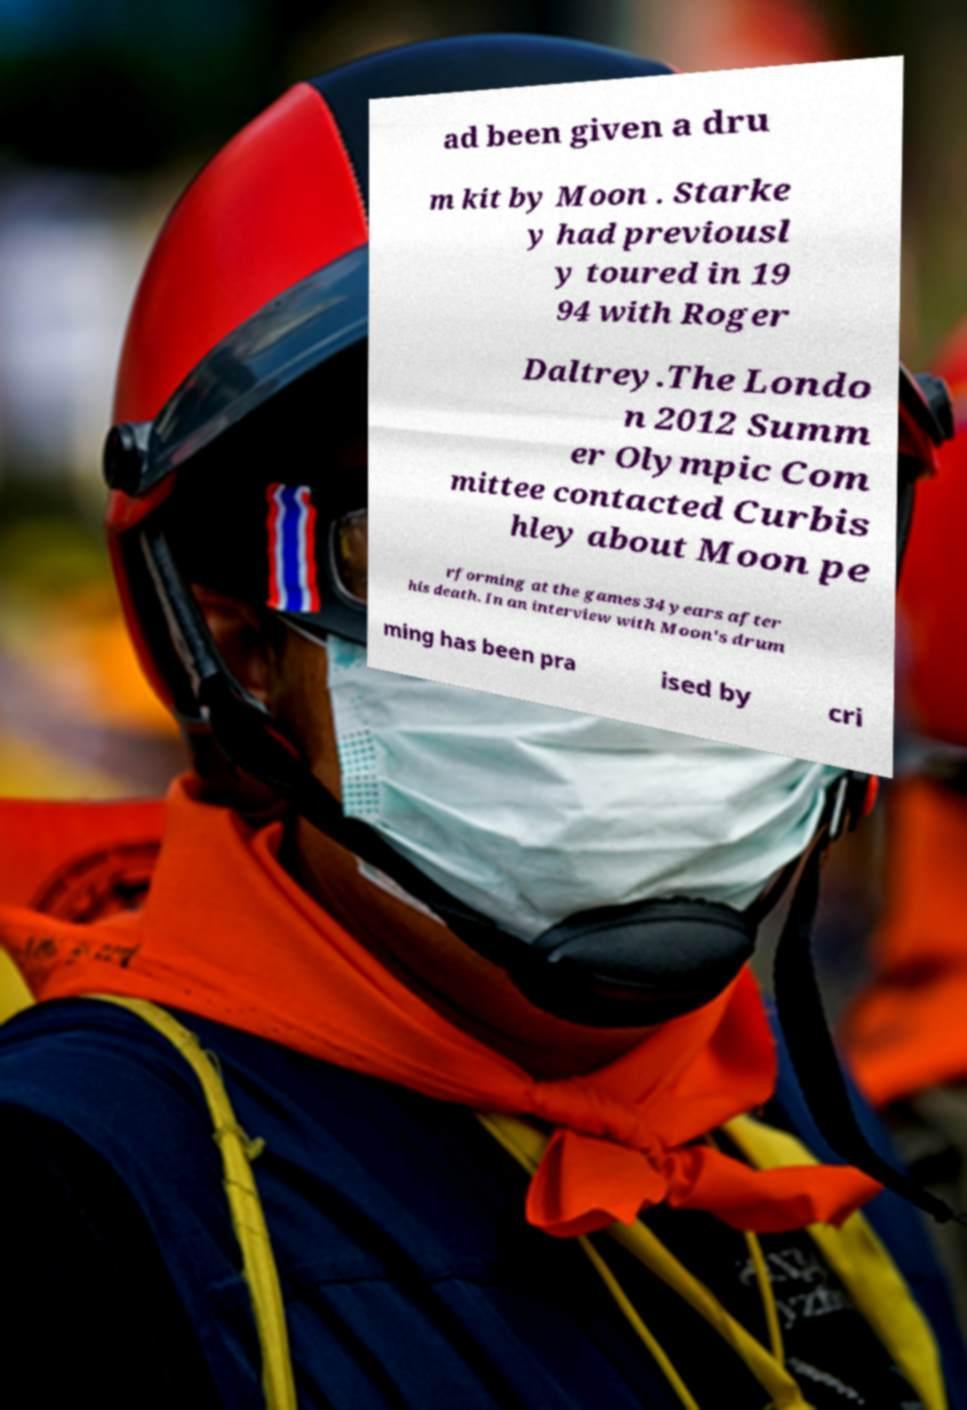Can you accurately transcribe the text from the provided image for me? ad been given a dru m kit by Moon . Starke y had previousl y toured in 19 94 with Roger Daltrey.The Londo n 2012 Summ er Olympic Com mittee contacted Curbis hley about Moon pe rforming at the games 34 years after his death. In an interview with Moon's drum ming has been pra ised by cri 